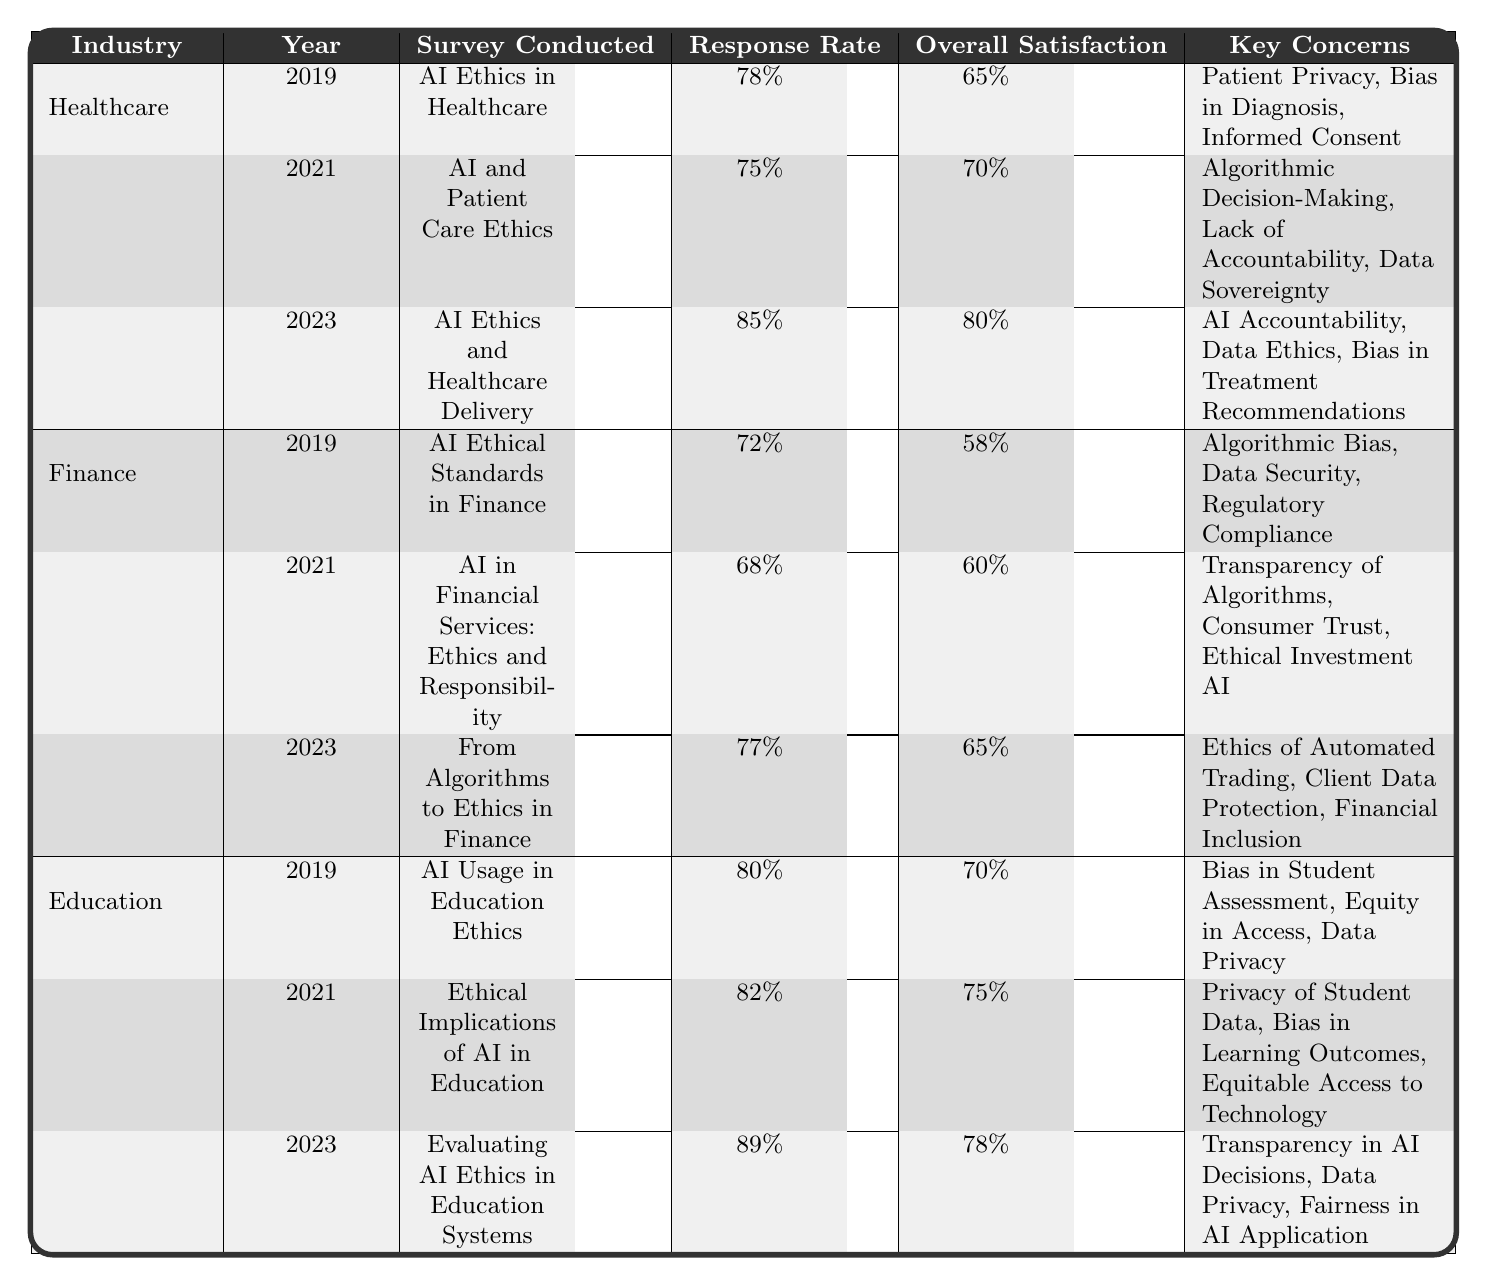What was the overall satisfaction in the finance industry in 2019? The overall satisfaction in the finance industry for 2019 is listed in the table under the corresponding year and industry. It shows 58%.
Answer: 58% Which industry had the highest response rate in 2023? In 2023, the education industry had the highest response rate of 89%. This value is compared with the other industries' response rates for the same year.
Answer: 89% What are the key concerns listed for healthcare in 2021? The key concerns for healthcare in 2021 are detailed in the table. They include Algorithmic Decision-Making, Lack of Accountability, and Data Sovereignty.
Answer: Algorithmic Decision-Making, Lack of Accountability, Data Sovereignty Which year saw the largest increase in overall satisfaction in the healthcare industry? To determine the largest increase in overall satisfaction for healthcare, we compare the values across the years: 65% (2019) to 70% (2021) and then to 80% (2023). The increase from 2021 to 2023 (10%) is the largest.
Answer: 10% increase from 2021 to 2023 Is there a trend in the response rates across the years for education? Looking at the response rates for education across the years: it was 80% in 2019, increased to 82% in 2021, and further rose to 89% in 2023. This indicates a positive upward trend.
Answer: Yes, there is an upward trend What was the difference in response rates between finance in 2019 and 2021? The response rate for finance in 2019 is 72% and in 2021 is 68%. The difference is calculated by subtracting 68% from 72%, yielding a decrease of 4%.
Answer: 4% decrease In which year did education achieve both the highest response rate and overall satisfaction? In 2023, education achieved the highest response rate of 89% and an overall satisfaction of 78%. No other year has these values higher for this industry.
Answer: 2023 What recommendations were made for finance in the 2021 survey? The recommendations for finance in the 2021 survey are stated clearly in the table: Enhance disclosure of AI usage and Encourage stakeholder engagement.
Answer: Enhance disclosure of AI usage, Encourage stakeholder engagement Did any industry have the same overall satisfaction rating in both 2019 and 2021? Checking the overall satisfaction ratings between 2019 and 2021 for all industries reveals: Healthcare (65% to 70%), Finance (58% to 60%), and Education (70% to 75%). All differ, so no industry matches.
Answer: No, none match Which industry's key concerns shifted from 'Bias' related issues to more accountability concerns from 2019 to 2021? In healthcare, the key concerns shifted specifically from ‘Bias in Diagnosis’ in 2019 to ‘Lack of Accountability’ in 2021, reflecting a change in focus.
Answer: Healthcare shifted key concerns What is the average overall satisfaction across all industries for 2023? The overall satisfaction for 2023 is: Healthcare (80%), Finance (65%), and Education (78%). Summing these gives 223; dividing by 3 for the average yields approximately 74.33%.
Answer: Approximately 74.33% 